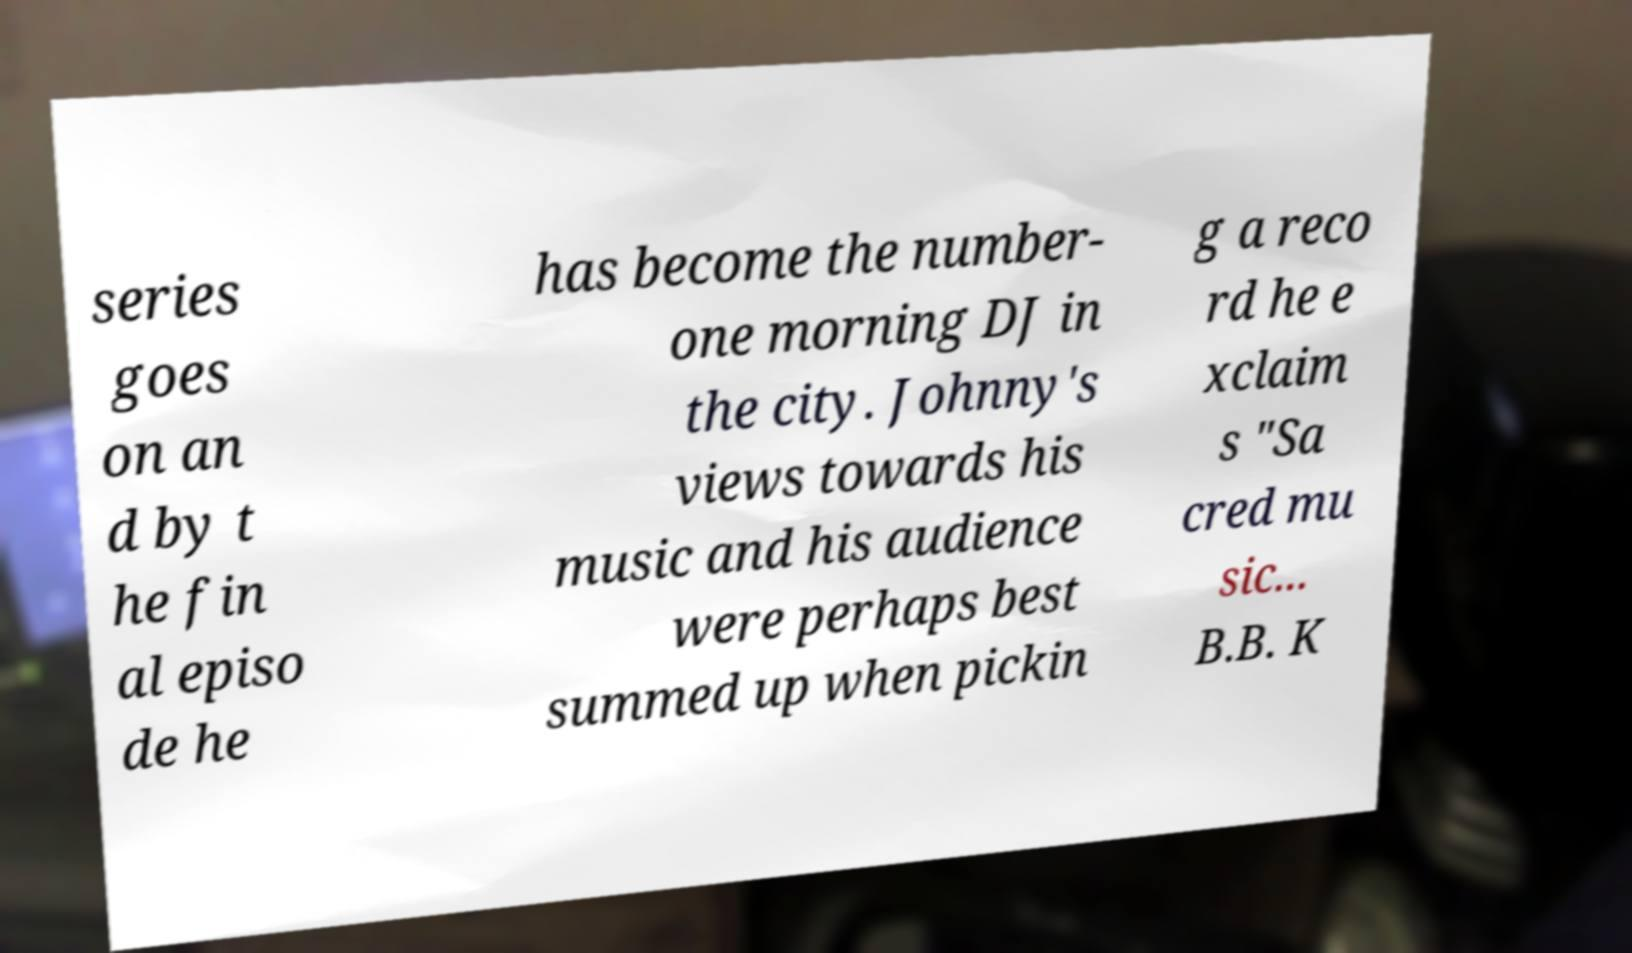Can you read and provide the text displayed in the image?This photo seems to have some interesting text. Can you extract and type it out for me? series goes on an d by t he fin al episo de he has become the number- one morning DJ in the city. Johnny's views towards his music and his audience were perhaps best summed up when pickin g a reco rd he e xclaim s "Sa cred mu sic... B.B. K 